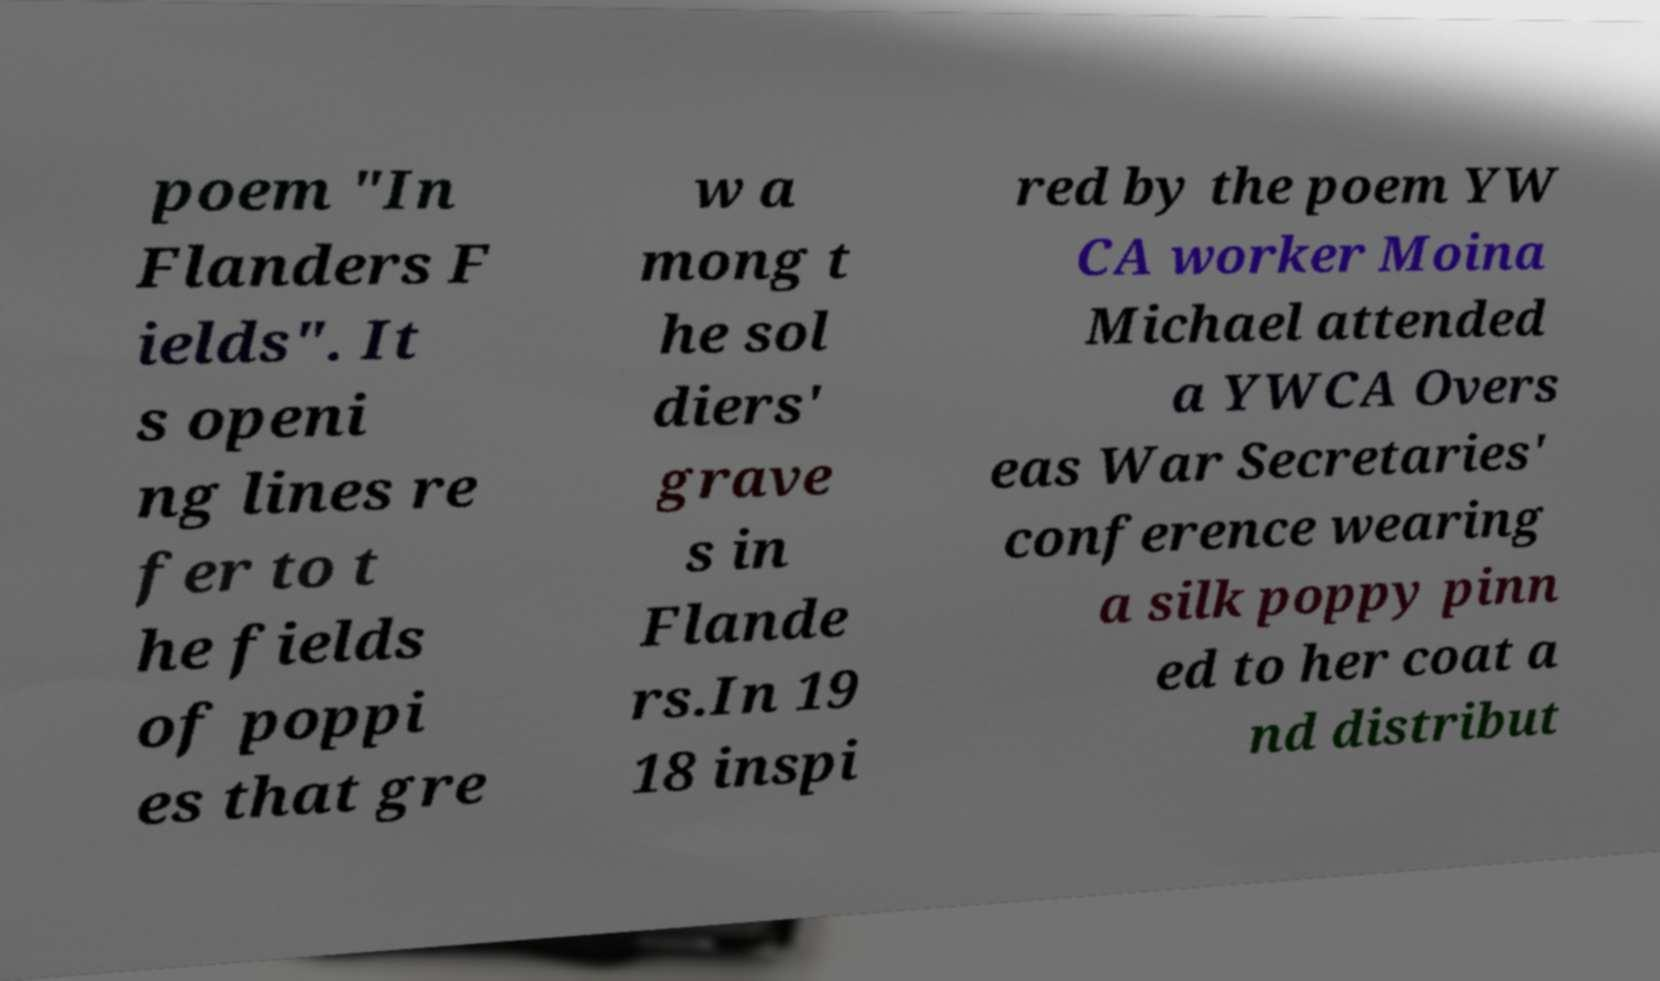For documentation purposes, I need the text within this image transcribed. Could you provide that? poem "In Flanders F ields". It s openi ng lines re fer to t he fields of poppi es that gre w a mong t he sol diers' grave s in Flande rs.In 19 18 inspi red by the poem YW CA worker Moina Michael attended a YWCA Overs eas War Secretaries' conference wearing a silk poppy pinn ed to her coat a nd distribut 